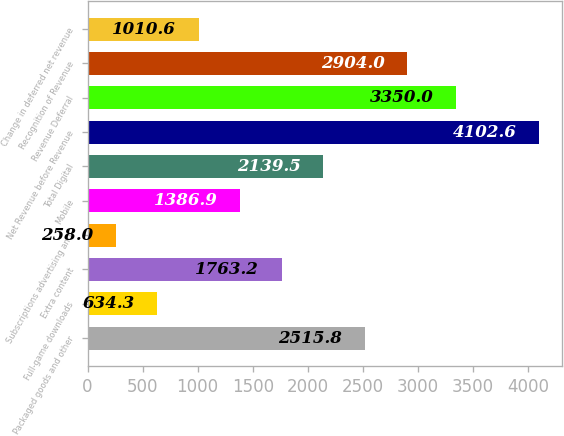<chart> <loc_0><loc_0><loc_500><loc_500><bar_chart><fcel>Packaged goods and other<fcel>Full-game downloads<fcel>Extra content<fcel>Subscriptions advertising and<fcel>Mobile<fcel>Total Digital<fcel>Net Revenue before Revenue<fcel>Revenue Deferral<fcel>Recognition of Revenue<fcel>Change in deferred net revenue<nl><fcel>2515.8<fcel>634.3<fcel>1763.2<fcel>258<fcel>1386.9<fcel>2139.5<fcel>4102.6<fcel>3350<fcel>2904<fcel>1010.6<nl></chart> 